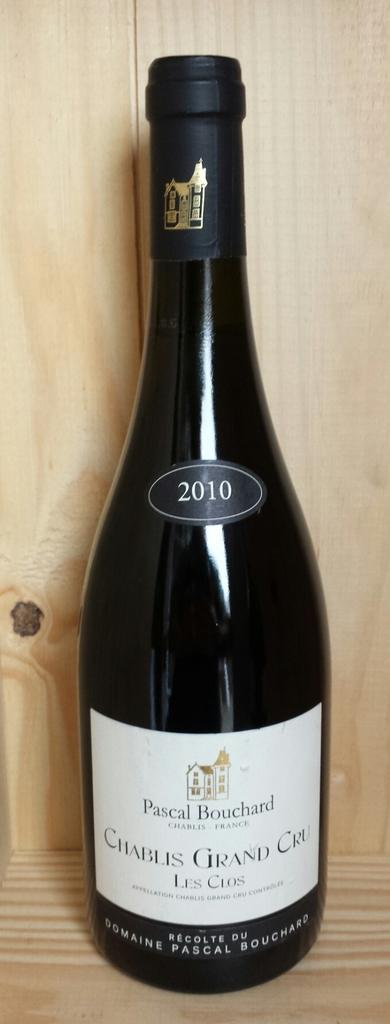What vineyard did this come from?
Your answer should be very brief. Pascal bouchard. 